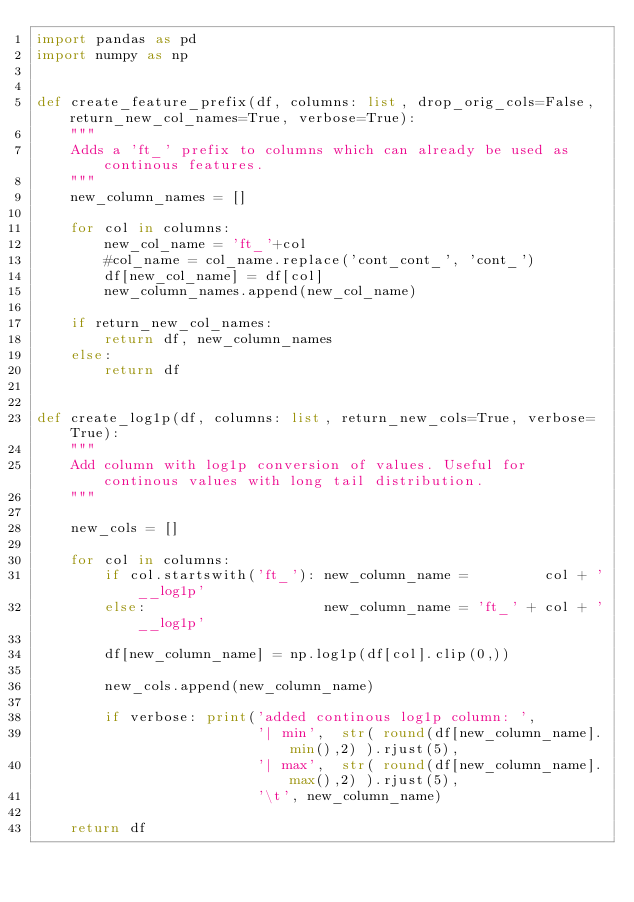<code> <loc_0><loc_0><loc_500><loc_500><_Python_>import pandas as pd
import numpy as np


def create_feature_prefix(df, columns: list, drop_orig_cols=False, return_new_col_names=True, verbose=True):
    """
    Adds a 'ft_' prefix to columns which can already be used as continous features.
    """
    new_column_names = []

    for col in columns:
        new_col_name = 'ft_'+col
        #col_name = col_name.replace('cont_cont_', 'cont_')
        df[new_col_name] = df[col]
        new_column_names.append(new_col_name)

    if return_new_col_names:
        return df, new_column_names
    else:
        return df


def create_log1p(df, columns: list, return_new_cols=True, verbose=True):
    """
    Add column with log1p conversion of values. Useful for continous values with long tail distribution.
    """
    
    new_cols = []
    
    for col in columns:
        if col.startswith('ft_'): new_column_name =         col + '__log1p'
        else:                     new_column_name = 'ft_' + col + '__log1p' 
        
        df[new_column_name] = np.log1p(df[col].clip(0,))
        
        new_cols.append(new_column_name)
            
        if verbose: print('added continous log1p column: ', 
                          '| min',  str( round(df[new_column_name].min(),2) ).rjust(5),
                          '| max',  str( round(df[new_column_name].max(),2) ).rjust(5),
                          '\t', new_column_name)
    
    return df

</code> 